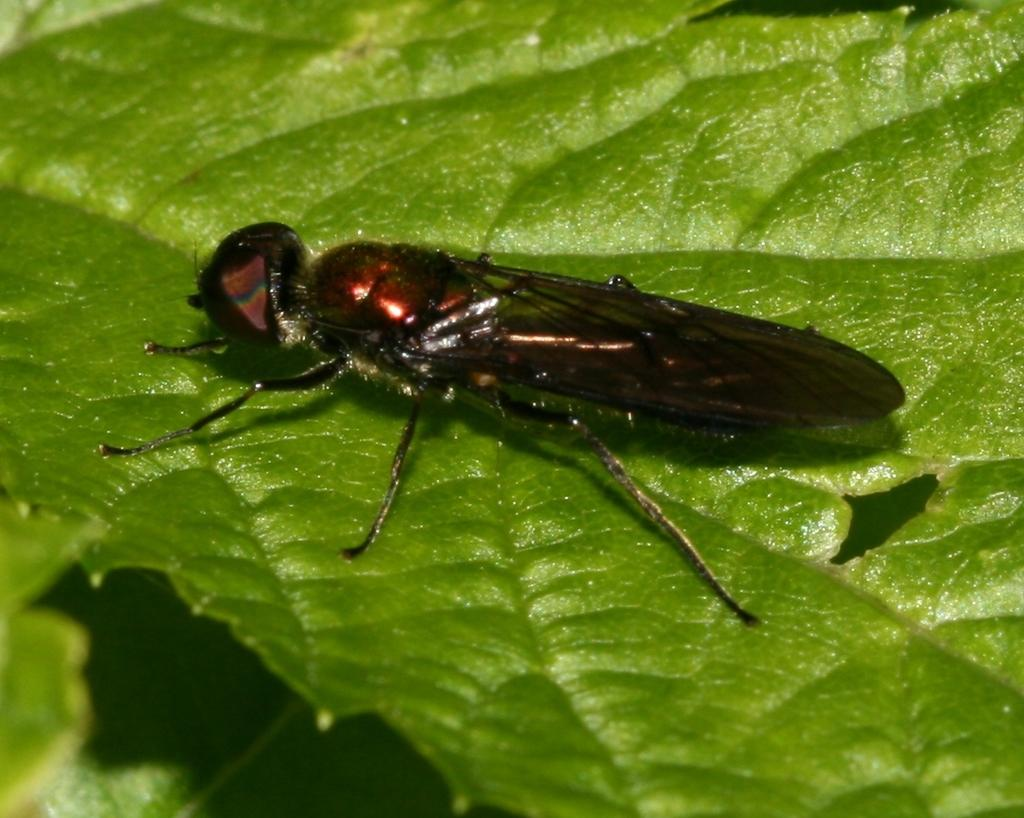What is located in the center of the image? There are leaves in the center of the image. Is there anything else on the leaves in the image? Yes, there is an insect on one of the leaves. What can be said about the color of the insect? The insect is brown in color. How many toes can be seen on the insect in the image? There are no toes visible on the insect in the image, as insects do not have toes. 